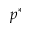Convert formula to latex. <formula><loc_0><loc_0><loc_500><loc_500>p ^ { * }</formula> 